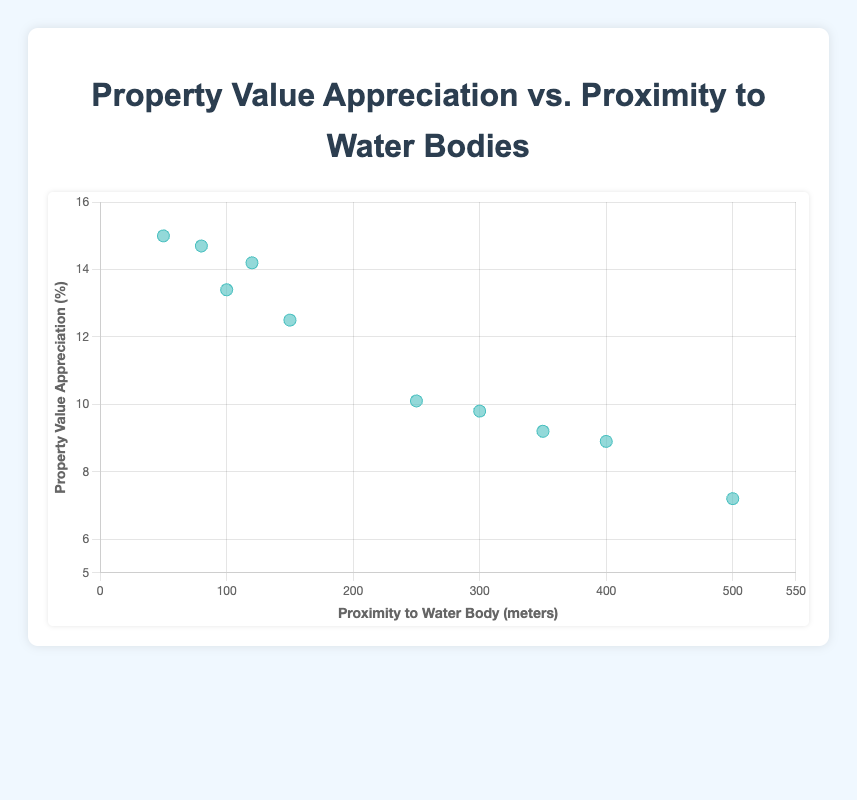what is the title of the figure? The title of the figure is prominently displayed at the top and reads "Property Value Appreciation vs. Proximity to Water Bodies".
Answer: Property Value Appreciation vs. Proximity to Water Bodies How many data points are displayed in the scatter plot? Counting the individual dots on the scatter plot, which represent properties, there are a total of 10 data points.
Answer: 10 What is the y-value for the property located 50 meters from a water body? Locate the point on the x-axis where x equals 50 meters and trace it vertically to the corresponding y-value, indicating property value appreciation. This value is 15.0 percent.
Answer: 15.0% Which property has the lowest appreciation rate, and what is its proximity to a water body? Identify the point with the smallest y-value on the scatter plot, which is 7.2 percent. This corresponds to a property located 500 meters from a water body.
Answer: 500 meters Is there a noticeable trend between proximity to water bodies and property value appreciation? The scatter plot shows that points closer to the left side (lower x-values) generally have higher y-values, indicating property value appreciation tends to be higher closer to water bodies.
Answer: Yes What is the approximate range of property value appreciation percentages shown in the figure? Identify the lowest and highest y-values on the scatter plot, which are 7.2% and 15.0%, respectively. The range is the difference between them: 15.0% - 7.2% = 7.8%.
Answer: 7.8% Which property has a proximity of 100 meters to the water body, and how much did it appreciate? Locate the point on the x-axis where x equals 100 meters and find the corresponding y-value, which is around 13.4%.
Answer: 13.4% What is the average property value appreciation for properties within 150 meters of the water body? Examine the scatter plot to identify properties located within 150 meters: 150m (12.5%), 50m (15.0%), 100m (13.4%), 120m (14.2%), 80m (14.7%). Calculate their average: (12.5+15.0 + 13.4 + 14.2 + 14.7) / 5 = 69.8 / 5 = 13.96%.
Answer: 13.96% How does the property appreciation at 400 meters compare to one at 250 meters? Locate the points on the x-axis at 400 meters (8.9%) and 250 meters (10.1%). Compare their y-values to determine that 400 meters has a lower appreciation than 250 meters.
Answer: Lower What is the median property value appreciation rate in the dataset? List the appreciation rates in ascending order: 7.2%, 8.9%, 9.2%, 9.8%, 10.1%, 12.5%, 13.4%, 14.2%, 14.7%, 15.0%. The median is the average of the 5th and 6th values: (10.1% + 12.5%) / 2 = 11.3%.
Answer: 11.3% 